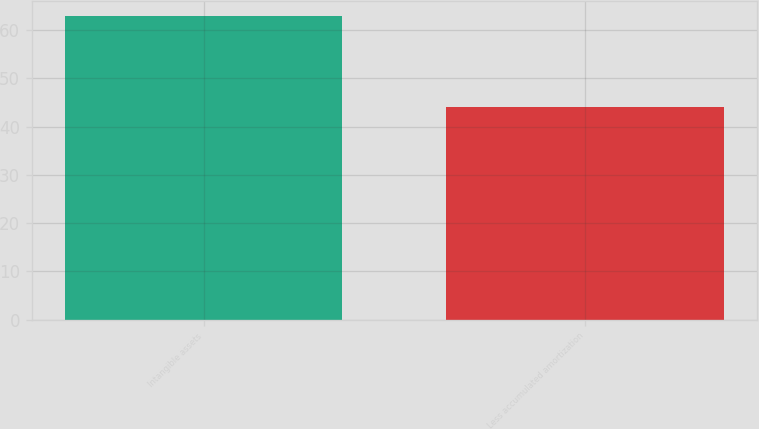Convert chart. <chart><loc_0><loc_0><loc_500><loc_500><bar_chart><fcel>Intangible assets<fcel>Less accumulated amortization<nl><fcel>63<fcel>44<nl></chart> 